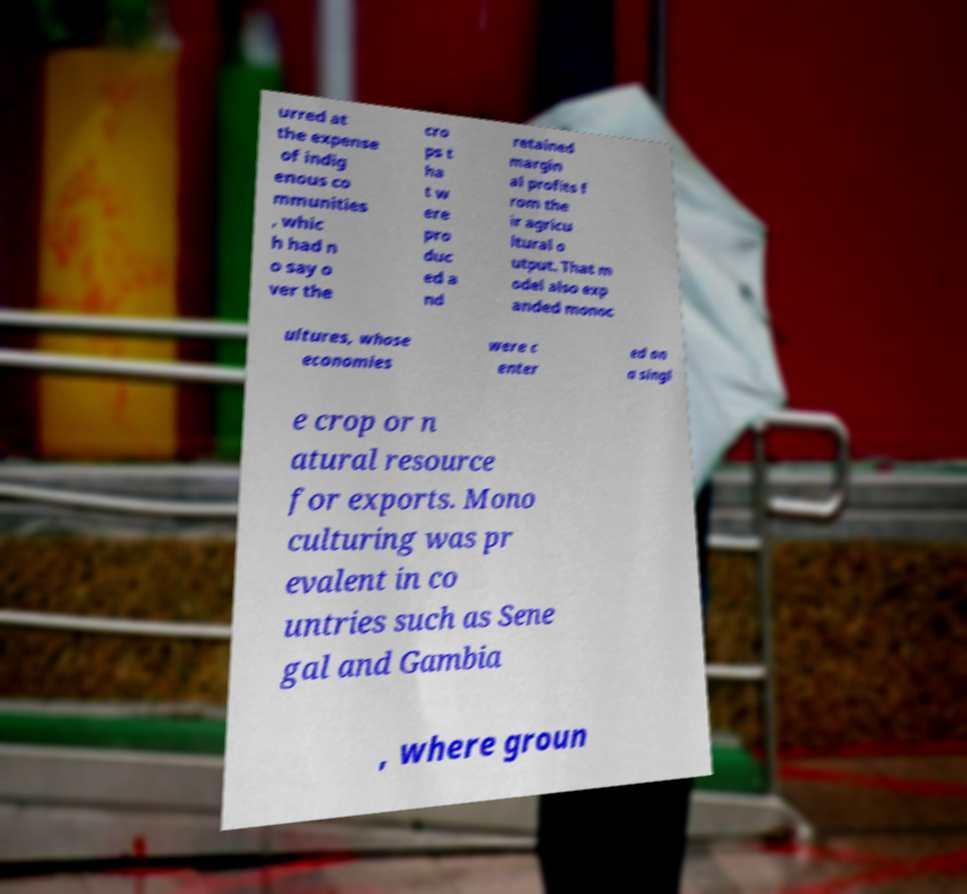Could you extract and type out the text from this image? urred at the expense of indig enous co mmunities , whic h had n o say o ver the cro ps t ha t w ere pro duc ed a nd retained margin al profits f rom the ir agricu ltural o utput. That m odel also exp anded monoc ultures, whose economies were c enter ed on a singl e crop or n atural resource for exports. Mono culturing was pr evalent in co untries such as Sene gal and Gambia , where groun 